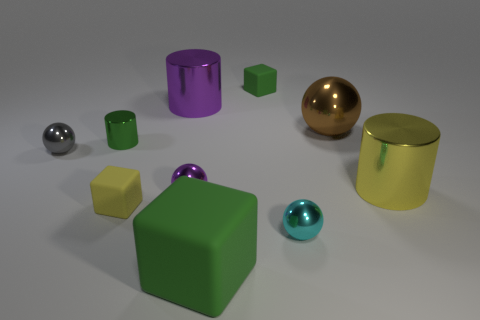What number of large things are green cylinders or purple metal cylinders?
Your answer should be very brief. 1. There is another block that is the same color as the big block; what is its material?
Provide a short and direct response. Rubber. Are there fewer large objects than yellow rubber cubes?
Provide a short and direct response. No. There is a green thing that is in front of the tiny gray thing; is it the same size as the green matte block that is behind the small yellow object?
Provide a succinct answer. No. How many purple objects are small matte balls or large blocks?
Offer a terse response. 0. What size is the metallic thing that is the same color as the big matte block?
Offer a very short reply. Small. Are there more tiny green blocks than purple things?
Ensure brevity in your answer.  No. Is the large matte object the same color as the small cylinder?
Provide a succinct answer. Yes. What number of objects are either green shiny things or metallic balls that are behind the gray thing?
Provide a short and direct response. 2. What number of other things are the same shape as the large yellow metal thing?
Ensure brevity in your answer.  2. 